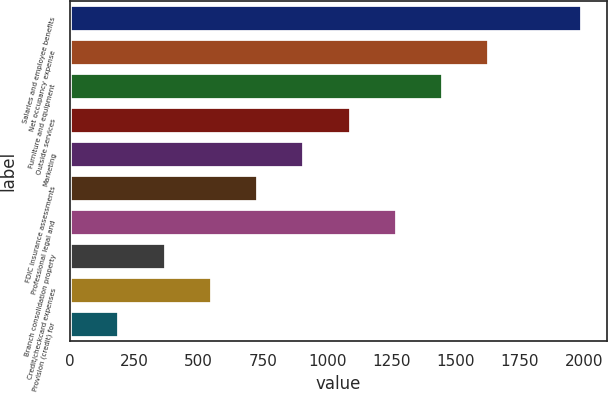<chart> <loc_0><loc_0><loc_500><loc_500><bar_chart><fcel>Salaries and employee benefits<fcel>Net occupancy expense<fcel>Furniture and equipment<fcel>Outside services<fcel>Marketing<fcel>FDIC insurance assessments<fcel>Professional legal and<fcel>Branch consolidation property<fcel>Credit/checkcard expenses<fcel>Provision (credit) for<nl><fcel>1989.8<fcel>1630.2<fcel>1450.4<fcel>1090.8<fcel>911<fcel>731.2<fcel>1270.6<fcel>371.6<fcel>551.4<fcel>191.8<nl></chart> 